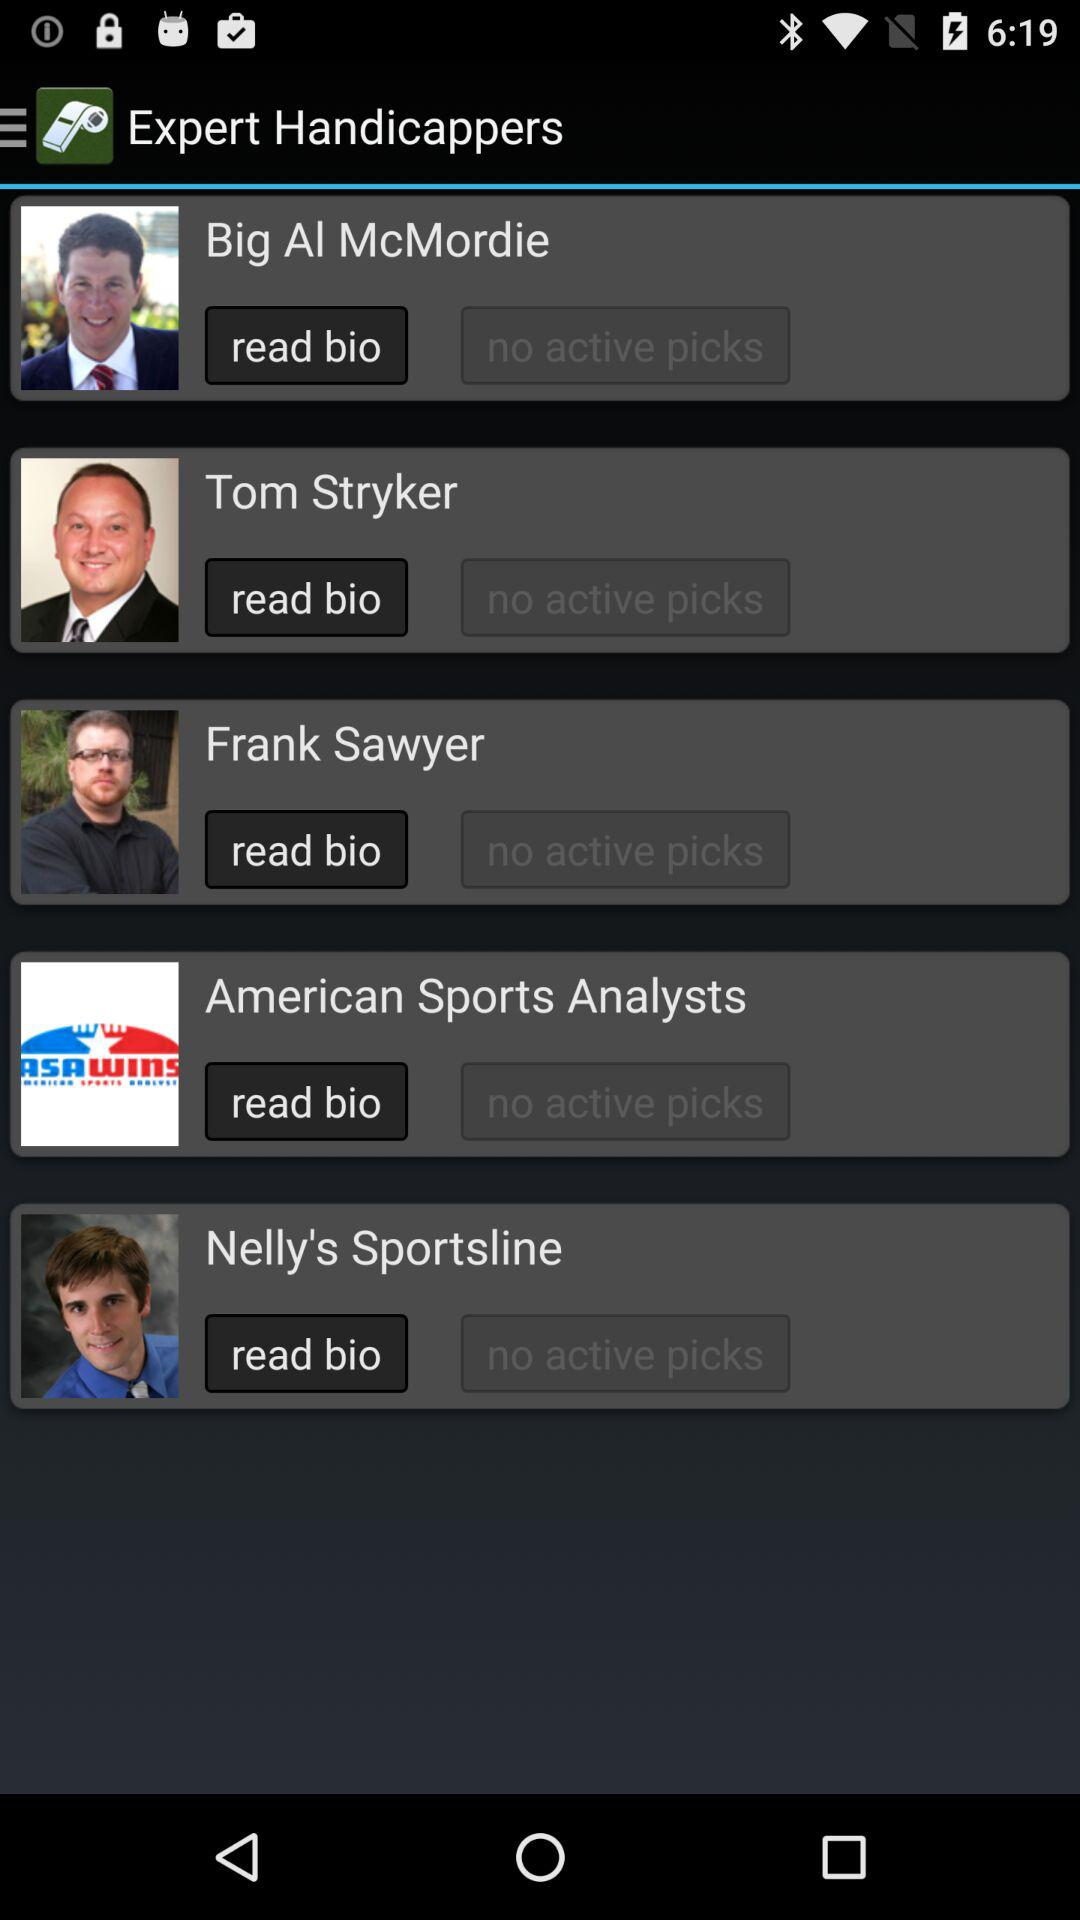Who are the expert handicappers? The expert handicappers are: Big Al McMordie, Tom Stryker, Frank Sawyer, "American Sports Analysts" and Nelly's Sportsline. 